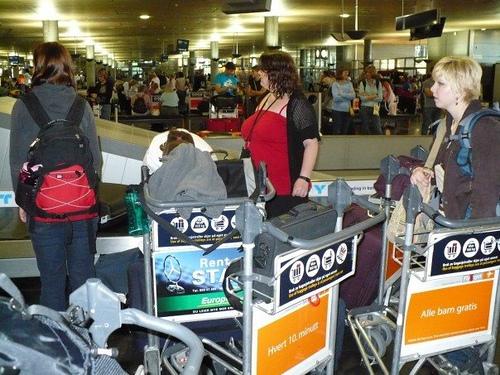Are those folding chairs?
Concise answer only. No. Is there a person with a backpack in the scene?
Write a very short answer. Yes. How many faces are visible?
Keep it brief. 2. 